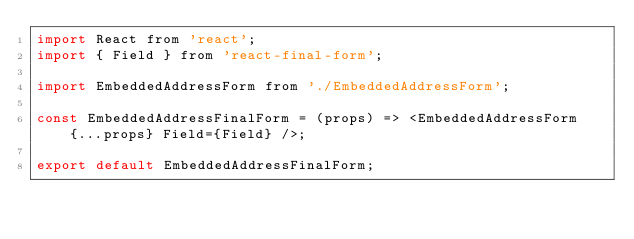<code> <loc_0><loc_0><loc_500><loc_500><_JavaScript_>import React from 'react';
import { Field } from 'react-final-form';

import EmbeddedAddressForm from './EmbeddedAddressForm';

const EmbeddedAddressFinalForm = (props) => <EmbeddedAddressForm {...props} Field={Field} />;

export default EmbeddedAddressFinalForm;

</code> 